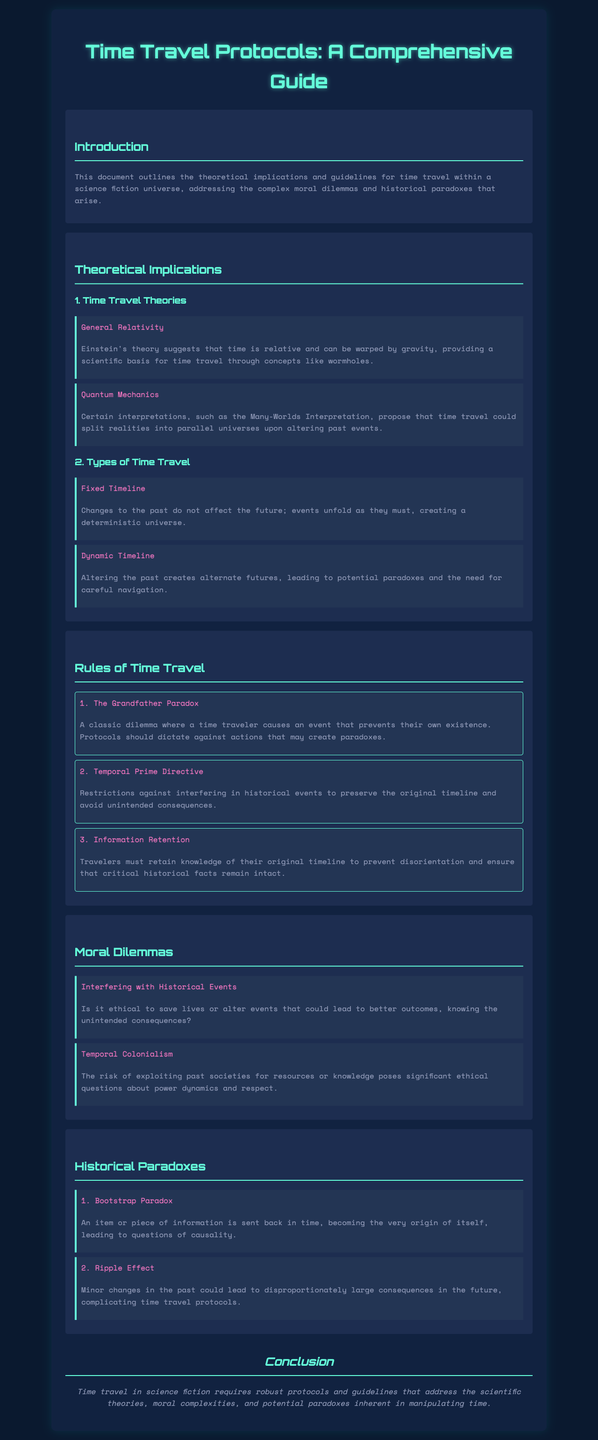What is the title of the document? The title is specified prominently at the top of the rendered document, which is "Time Travel Protocols: A Comprehensive Guide."
Answer: Time Travel Protocols: A Comprehensive Guide How many time travel theories are mentioned? The section lists two theories under the "Time Travel Theories" heading, which are General Relativity and Quantum Mechanics.
Answer: 2 What is the first rule of time travel? The first rule is explicitly stated in the "Rules of Time Travel" section, titled "The Grandfather Paradox."
Answer: The Grandfather Paradox Which ethical dilemma pertains to altering historical events? This dilemma is highlighted under the "Moral Dilemmas" section, specifically titled "Interfering with Historical Events."
Answer: Interfering with Historical Events What is the Bootstrap Paradox related to? The Bootstrap Paradox is described in terms of causality and refers to a situation where an item is sent back in time and becomes its own origin.
Answer: Causality What color is the background of the document? The document's background color is indicated in the style section of the HTML, which is a dark blue-gray tone.
Answer: Dark blue-gray How many types of time travel are discussed? The document mentions two types: Fixed Timeline and Dynamic Timeline.
Answer: 2 What important directive restricts historical interference? The directive is referred to as "Temporal Prime Directive" in the "Rules of Time Travel" section.
Answer: Temporal Prime Directive 